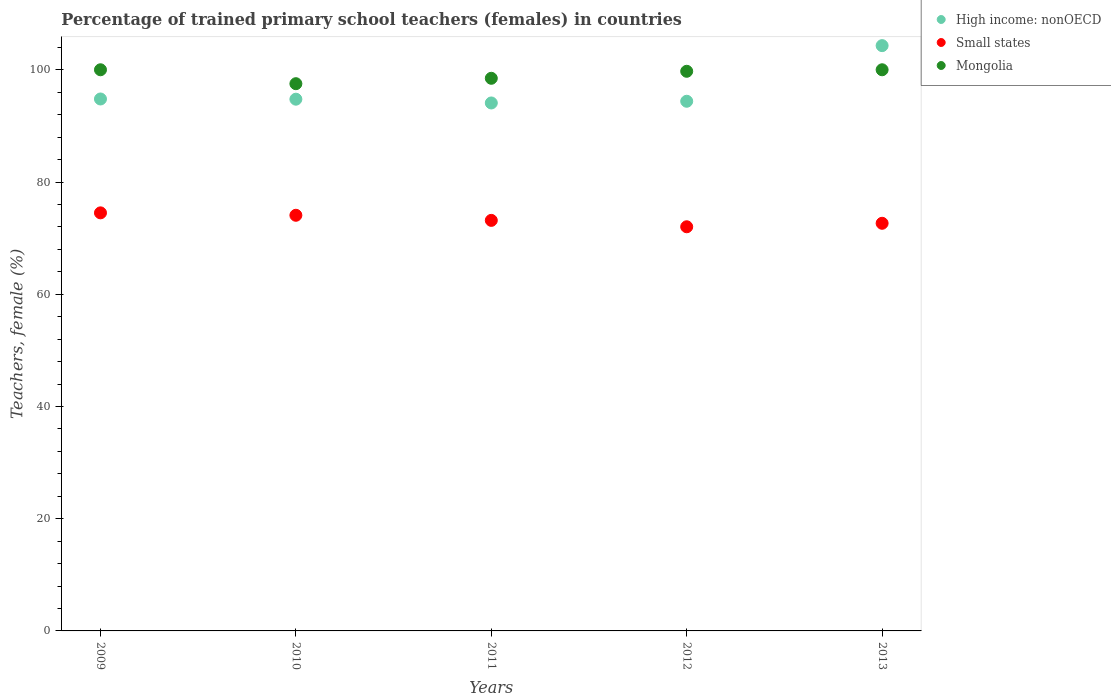How many different coloured dotlines are there?
Provide a succinct answer. 3. Is the number of dotlines equal to the number of legend labels?
Offer a terse response. Yes. What is the percentage of trained primary school teachers (females) in High income: nonOECD in 2010?
Offer a terse response. 94.76. Across all years, what is the maximum percentage of trained primary school teachers (females) in Mongolia?
Ensure brevity in your answer.  100. Across all years, what is the minimum percentage of trained primary school teachers (females) in High income: nonOECD?
Your answer should be compact. 94.08. In which year was the percentage of trained primary school teachers (females) in Small states maximum?
Make the answer very short. 2009. What is the total percentage of trained primary school teachers (females) in Mongolia in the graph?
Offer a terse response. 495.73. What is the difference between the percentage of trained primary school teachers (females) in Small states in 2009 and that in 2012?
Ensure brevity in your answer.  2.48. What is the difference between the percentage of trained primary school teachers (females) in High income: nonOECD in 2011 and the percentage of trained primary school teachers (females) in Small states in 2012?
Offer a very short reply. 22.06. What is the average percentage of trained primary school teachers (females) in Small states per year?
Ensure brevity in your answer.  73.28. In the year 2009, what is the difference between the percentage of trained primary school teachers (females) in Mongolia and percentage of trained primary school teachers (females) in High income: nonOECD?
Keep it short and to the point. 5.21. What is the ratio of the percentage of trained primary school teachers (females) in Mongolia in 2010 to that in 2012?
Keep it short and to the point. 0.98. Is the percentage of trained primary school teachers (females) in Mongolia in 2009 less than that in 2012?
Your answer should be compact. No. What is the difference between the highest and the second highest percentage of trained primary school teachers (females) in Small states?
Provide a succinct answer. 0.43. What is the difference between the highest and the lowest percentage of trained primary school teachers (females) in Mongolia?
Your answer should be very brief. 2.48. In how many years, is the percentage of trained primary school teachers (females) in Mongolia greater than the average percentage of trained primary school teachers (females) in Mongolia taken over all years?
Make the answer very short. 3. Is the percentage of trained primary school teachers (females) in Small states strictly less than the percentage of trained primary school teachers (females) in High income: nonOECD over the years?
Ensure brevity in your answer.  Yes. What is the difference between two consecutive major ticks on the Y-axis?
Ensure brevity in your answer.  20. Are the values on the major ticks of Y-axis written in scientific E-notation?
Make the answer very short. No. Does the graph contain grids?
Provide a succinct answer. No. Where does the legend appear in the graph?
Make the answer very short. Top right. How are the legend labels stacked?
Your answer should be very brief. Vertical. What is the title of the graph?
Ensure brevity in your answer.  Percentage of trained primary school teachers (females) in countries. What is the label or title of the Y-axis?
Your answer should be very brief. Teachers, female (%). What is the Teachers, female (%) in High income: nonOECD in 2009?
Offer a very short reply. 94.79. What is the Teachers, female (%) of Small states in 2009?
Provide a short and direct response. 74.5. What is the Teachers, female (%) in Mongolia in 2009?
Keep it short and to the point. 100. What is the Teachers, female (%) of High income: nonOECD in 2010?
Keep it short and to the point. 94.76. What is the Teachers, female (%) of Small states in 2010?
Offer a very short reply. 74.07. What is the Teachers, female (%) of Mongolia in 2010?
Provide a succinct answer. 97.52. What is the Teachers, female (%) of High income: nonOECD in 2011?
Ensure brevity in your answer.  94.08. What is the Teachers, female (%) of Small states in 2011?
Keep it short and to the point. 73.16. What is the Teachers, female (%) of Mongolia in 2011?
Provide a short and direct response. 98.48. What is the Teachers, female (%) of High income: nonOECD in 2012?
Give a very brief answer. 94.39. What is the Teachers, female (%) of Small states in 2012?
Your response must be concise. 72.02. What is the Teachers, female (%) of Mongolia in 2012?
Offer a very short reply. 99.73. What is the Teachers, female (%) of High income: nonOECD in 2013?
Give a very brief answer. 104.3. What is the Teachers, female (%) of Small states in 2013?
Your response must be concise. 72.64. What is the Teachers, female (%) in Mongolia in 2013?
Make the answer very short. 100. Across all years, what is the maximum Teachers, female (%) of High income: nonOECD?
Provide a short and direct response. 104.3. Across all years, what is the maximum Teachers, female (%) in Small states?
Provide a succinct answer. 74.5. Across all years, what is the maximum Teachers, female (%) of Mongolia?
Offer a very short reply. 100. Across all years, what is the minimum Teachers, female (%) in High income: nonOECD?
Give a very brief answer. 94.08. Across all years, what is the minimum Teachers, female (%) in Small states?
Provide a succinct answer. 72.02. Across all years, what is the minimum Teachers, female (%) in Mongolia?
Make the answer very short. 97.52. What is the total Teachers, female (%) of High income: nonOECD in the graph?
Make the answer very short. 482.33. What is the total Teachers, female (%) in Small states in the graph?
Your response must be concise. 366.4. What is the total Teachers, female (%) of Mongolia in the graph?
Make the answer very short. 495.73. What is the difference between the Teachers, female (%) in High income: nonOECD in 2009 and that in 2010?
Keep it short and to the point. 0.04. What is the difference between the Teachers, female (%) in Small states in 2009 and that in 2010?
Offer a very short reply. 0.43. What is the difference between the Teachers, female (%) of Mongolia in 2009 and that in 2010?
Your answer should be very brief. 2.48. What is the difference between the Teachers, female (%) in High income: nonOECD in 2009 and that in 2011?
Your answer should be compact. 0.71. What is the difference between the Teachers, female (%) of Small states in 2009 and that in 2011?
Make the answer very short. 1.34. What is the difference between the Teachers, female (%) in Mongolia in 2009 and that in 2011?
Make the answer very short. 1.52. What is the difference between the Teachers, female (%) in High income: nonOECD in 2009 and that in 2012?
Offer a terse response. 0.41. What is the difference between the Teachers, female (%) in Small states in 2009 and that in 2012?
Your answer should be very brief. 2.48. What is the difference between the Teachers, female (%) of Mongolia in 2009 and that in 2012?
Your answer should be very brief. 0.27. What is the difference between the Teachers, female (%) in High income: nonOECD in 2009 and that in 2013?
Provide a succinct answer. -9.51. What is the difference between the Teachers, female (%) in Small states in 2009 and that in 2013?
Offer a terse response. 1.86. What is the difference between the Teachers, female (%) in High income: nonOECD in 2010 and that in 2011?
Make the answer very short. 0.67. What is the difference between the Teachers, female (%) in Small states in 2010 and that in 2011?
Offer a very short reply. 0.91. What is the difference between the Teachers, female (%) in Mongolia in 2010 and that in 2011?
Offer a terse response. -0.96. What is the difference between the Teachers, female (%) of High income: nonOECD in 2010 and that in 2012?
Your response must be concise. 0.37. What is the difference between the Teachers, female (%) of Small states in 2010 and that in 2012?
Offer a terse response. 2.05. What is the difference between the Teachers, female (%) of Mongolia in 2010 and that in 2012?
Keep it short and to the point. -2.21. What is the difference between the Teachers, female (%) in High income: nonOECD in 2010 and that in 2013?
Offer a terse response. -9.54. What is the difference between the Teachers, female (%) in Small states in 2010 and that in 2013?
Your response must be concise. 1.43. What is the difference between the Teachers, female (%) in Mongolia in 2010 and that in 2013?
Offer a very short reply. -2.48. What is the difference between the Teachers, female (%) in High income: nonOECD in 2011 and that in 2012?
Give a very brief answer. -0.3. What is the difference between the Teachers, female (%) in Small states in 2011 and that in 2012?
Offer a terse response. 1.14. What is the difference between the Teachers, female (%) in Mongolia in 2011 and that in 2012?
Provide a succinct answer. -1.25. What is the difference between the Teachers, female (%) of High income: nonOECD in 2011 and that in 2013?
Give a very brief answer. -10.22. What is the difference between the Teachers, female (%) of Small states in 2011 and that in 2013?
Your response must be concise. 0.52. What is the difference between the Teachers, female (%) in Mongolia in 2011 and that in 2013?
Offer a very short reply. -1.52. What is the difference between the Teachers, female (%) in High income: nonOECD in 2012 and that in 2013?
Provide a succinct answer. -9.91. What is the difference between the Teachers, female (%) in Small states in 2012 and that in 2013?
Ensure brevity in your answer.  -0.62. What is the difference between the Teachers, female (%) of Mongolia in 2012 and that in 2013?
Give a very brief answer. -0.27. What is the difference between the Teachers, female (%) in High income: nonOECD in 2009 and the Teachers, female (%) in Small states in 2010?
Ensure brevity in your answer.  20.72. What is the difference between the Teachers, female (%) of High income: nonOECD in 2009 and the Teachers, female (%) of Mongolia in 2010?
Provide a short and direct response. -2.72. What is the difference between the Teachers, female (%) of Small states in 2009 and the Teachers, female (%) of Mongolia in 2010?
Provide a succinct answer. -23.02. What is the difference between the Teachers, female (%) of High income: nonOECD in 2009 and the Teachers, female (%) of Small states in 2011?
Offer a very short reply. 21.63. What is the difference between the Teachers, female (%) in High income: nonOECD in 2009 and the Teachers, female (%) in Mongolia in 2011?
Offer a very short reply. -3.69. What is the difference between the Teachers, female (%) in Small states in 2009 and the Teachers, female (%) in Mongolia in 2011?
Offer a very short reply. -23.98. What is the difference between the Teachers, female (%) in High income: nonOECD in 2009 and the Teachers, female (%) in Small states in 2012?
Keep it short and to the point. 22.77. What is the difference between the Teachers, female (%) of High income: nonOECD in 2009 and the Teachers, female (%) of Mongolia in 2012?
Your answer should be compact. -4.94. What is the difference between the Teachers, female (%) of Small states in 2009 and the Teachers, female (%) of Mongolia in 2012?
Make the answer very short. -25.23. What is the difference between the Teachers, female (%) of High income: nonOECD in 2009 and the Teachers, female (%) of Small states in 2013?
Provide a short and direct response. 22.15. What is the difference between the Teachers, female (%) in High income: nonOECD in 2009 and the Teachers, female (%) in Mongolia in 2013?
Make the answer very short. -5.21. What is the difference between the Teachers, female (%) in Small states in 2009 and the Teachers, female (%) in Mongolia in 2013?
Your answer should be compact. -25.5. What is the difference between the Teachers, female (%) in High income: nonOECD in 2010 and the Teachers, female (%) in Small states in 2011?
Offer a terse response. 21.6. What is the difference between the Teachers, female (%) in High income: nonOECD in 2010 and the Teachers, female (%) in Mongolia in 2011?
Offer a very short reply. -3.72. What is the difference between the Teachers, female (%) of Small states in 2010 and the Teachers, female (%) of Mongolia in 2011?
Provide a short and direct response. -24.41. What is the difference between the Teachers, female (%) in High income: nonOECD in 2010 and the Teachers, female (%) in Small states in 2012?
Offer a terse response. 22.74. What is the difference between the Teachers, female (%) of High income: nonOECD in 2010 and the Teachers, female (%) of Mongolia in 2012?
Your answer should be very brief. -4.97. What is the difference between the Teachers, female (%) in Small states in 2010 and the Teachers, female (%) in Mongolia in 2012?
Offer a terse response. -25.66. What is the difference between the Teachers, female (%) of High income: nonOECD in 2010 and the Teachers, female (%) of Small states in 2013?
Offer a very short reply. 22.12. What is the difference between the Teachers, female (%) in High income: nonOECD in 2010 and the Teachers, female (%) in Mongolia in 2013?
Your answer should be compact. -5.24. What is the difference between the Teachers, female (%) of Small states in 2010 and the Teachers, female (%) of Mongolia in 2013?
Give a very brief answer. -25.93. What is the difference between the Teachers, female (%) of High income: nonOECD in 2011 and the Teachers, female (%) of Small states in 2012?
Your response must be concise. 22.06. What is the difference between the Teachers, female (%) in High income: nonOECD in 2011 and the Teachers, female (%) in Mongolia in 2012?
Keep it short and to the point. -5.64. What is the difference between the Teachers, female (%) in Small states in 2011 and the Teachers, female (%) in Mongolia in 2012?
Give a very brief answer. -26.57. What is the difference between the Teachers, female (%) of High income: nonOECD in 2011 and the Teachers, female (%) of Small states in 2013?
Provide a short and direct response. 21.44. What is the difference between the Teachers, female (%) in High income: nonOECD in 2011 and the Teachers, female (%) in Mongolia in 2013?
Your response must be concise. -5.92. What is the difference between the Teachers, female (%) in Small states in 2011 and the Teachers, female (%) in Mongolia in 2013?
Give a very brief answer. -26.84. What is the difference between the Teachers, female (%) in High income: nonOECD in 2012 and the Teachers, female (%) in Small states in 2013?
Provide a succinct answer. 21.75. What is the difference between the Teachers, female (%) in High income: nonOECD in 2012 and the Teachers, female (%) in Mongolia in 2013?
Keep it short and to the point. -5.61. What is the difference between the Teachers, female (%) of Small states in 2012 and the Teachers, female (%) of Mongolia in 2013?
Provide a short and direct response. -27.98. What is the average Teachers, female (%) in High income: nonOECD per year?
Keep it short and to the point. 96.47. What is the average Teachers, female (%) of Small states per year?
Give a very brief answer. 73.28. What is the average Teachers, female (%) of Mongolia per year?
Provide a succinct answer. 99.15. In the year 2009, what is the difference between the Teachers, female (%) of High income: nonOECD and Teachers, female (%) of Small states?
Your answer should be very brief. 20.29. In the year 2009, what is the difference between the Teachers, female (%) of High income: nonOECD and Teachers, female (%) of Mongolia?
Make the answer very short. -5.21. In the year 2009, what is the difference between the Teachers, female (%) in Small states and Teachers, female (%) in Mongolia?
Offer a terse response. -25.5. In the year 2010, what is the difference between the Teachers, female (%) of High income: nonOECD and Teachers, female (%) of Small states?
Give a very brief answer. 20.69. In the year 2010, what is the difference between the Teachers, female (%) of High income: nonOECD and Teachers, female (%) of Mongolia?
Keep it short and to the point. -2.76. In the year 2010, what is the difference between the Teachers, female (%) in Small states and Teachers, female (%) in Mongolia?
Give a very brief answer. -23.45. In the year 2011, what is the difference between the Teachers, female (%) in High income: nonOECD and Teachers, female (%) in Small states?
Offer a very short reply. 20.92. In the year 2011, what is the difference between the Teachers, female (%) in High income: nonOECD and Teachers, female (%) in Mongolia?
Offer a very short reply. -4.4. In the year 2011, what is the difference between the Teachers, female (%) of Small states and Teachers, female (%) of Mongolia?
Ensure brevity in your answer.  -25.32. In the year 2012, what is the difference between the Teachers, female (%) of High income: nonOECD and Teachers, female (%) of Small states?
Provide a succinct answer. 22.37. In the year 2012, what is the difference between the Teachers, female (%) in High income: nonOECD and Teachers, female (%) in Mongolia?
Provide a short and direct response. -5.34. In the year 2012, what is the difference between the Teachers, female (%) in Small states and Teachers, female (%) in Mongolia?
Ensure brevity in your answer.  -27.71. In the year 2013, what is the difference between the Teachers, female (%) of High income: nonOECD and Teachers, female (%) of Small states?
Make the answer very short. 31.66. In the year 2013, what is the difference between the Teachers, female (%) of High income: nonOECD and Teachers, female (%) of Mongolia?
Provide a short and direct response. 4.3. In the year 2013, what is the difference between the Teachers, female (%) of Small states and Teachers, female (%) of Mongolia?
Provide a succinct answer. -27.36. What is the ratio of the Teachers, female (%) of High income: nonOECD in 2009 to that in 2010?
Your answer should be compact. 1. What is the ratio of the Teachers, female (%) of Mongolia in 2009 to that in 2010?
Your answer should be very brief. 1.03. What is the ratio of the Teachers, female (%) in High income: nonOECD in 2009 to that in 2011?
Ensure brevity in your answer.  1.01. What is the ratio of the Teachers, female (%) of Small states in 2009 to that in 2011?
Offer a terse response. 1.02. What is the ratio of the Teachers, female (%) of Mongolia in 2009 to that in 2011?
Your answer should be very brief. 1.02. What is the ratio of the Teachers, female (%) in Small states in 2009 to that in 2012?
Your answer should be compact. 1.03. What is the ratio of the Teachers, female (%) in High income: nonOECD in 2009 to that in 2013?
Ensure brevity in your answer.  0.91. What is the ratio of the Teachers, female (%) of Small states in 2009 to that in 2013?
Keep it short and to the point. 1.03. What is the ratio of the Teachers, female (%) in Mongolia in 2009 to that in 2013?
Your answer should be compact. 1. What is the ratio of the Teachers, female (%) in High income: nonOECD in 2010 to that in 2011?
Ensure brevity in your answer.  1.01. What is the ratio of the Teachers, female (%) of Small states in 2010 to that in 2011?
Ensure brevity in your answer.  1.01. What is the ratio of the Teachers, female (%) in Mongolia in 2010 to that in 2011?
Offer a very short reply. 0.99. What is the ratio of the Teachers, female (%) of High income: nonOECD in 2010 to that in 2012?
Your answer should be very brief. 1. What is the ratio of the Teachers, female (%) of Small states in 2010 to that in 2012?
Provide a succinct answer. 1.03. What is the ratio of the Teachers, female (%) of Mongolia in 2010 to that in 2012?
Give a very brief answer. 0.98. What is the ratio of the Teachers, female (%) in High income: nonOECD in 2010 to that in 2013?
Your answer should be compact. 0.91. What is the ratio of the Teachers, female (%) in Small states in 2010 to that in 2013?
Your answer should be very brief. 1.02. What is the ratio of the Teachers, female (%) of Mongolia in 2010 to that in 2013?
Provide a succinct answer. 0.98. What is the ratio of the Teachers, female (%) in Small states in 2011 to that in 2012?
Offer a terse response. 1.02. What is the ratio of the Teachers, female (%) in Mongolia in 2011 to that in 2012?
Your answer should be very brief. 0.99. What is the ratio of the Teachers, female (%) in High income: nonOECD in 2011 to that in 2013?
Make the answer very short. 0.9. What is the ratio of the Teachers, female (%) in Small states in 2011 to that in 2013?
Your answer should be compact. 1.01. What is the ratio of the Teachers, female (%) of High income: nonOECD in 2012 to that in 2013?
Provide a short and direct response. 0.91. What is the ratio of the Teachers, female (%) in Small states in 2012 to that in 2013?
Your response must be concise. 0.99. What is the difference between the highest and the second highest Teachers, female (%) of High income: nonOECD?
Offer a terse response. 9.51. What is the difference between the highest and the second highest Teachers, female (%) in Small states?
Provide a succinct answer. 0.43. What is the difference between the highest and the lowest Teachers, female (%) of High income: nonOECD?
Give a very brief answer. 10.22. What is the difference between the highest and the lowest Teachers, female (%) of Small states?
Provide a succinct answer. 2.48. What is the difference between the highest and the lowest Teachers, female (%) in Mongolia?
Your answer should be very brief. 2.48. 